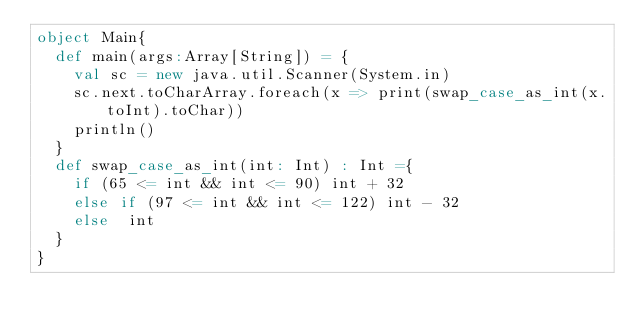<code> <loc_0><loc_0><loc_500><loc_500><_Scala_>object Main{
  def main(args:Array[String]) = {
    val sc = new java.util.Scanner(System.in)
    sc.next.toCharArray.foreach(x => print(swap_case_as_int(x.toInt).toChar))
    println()
  }
  def swap_case_as_int(int: Int) : Int ={
    if (65 <= int && int <= 90) int + 32
    else if (97 <= int && int <= 122) int - 32
    else  int
  }
}</code> 